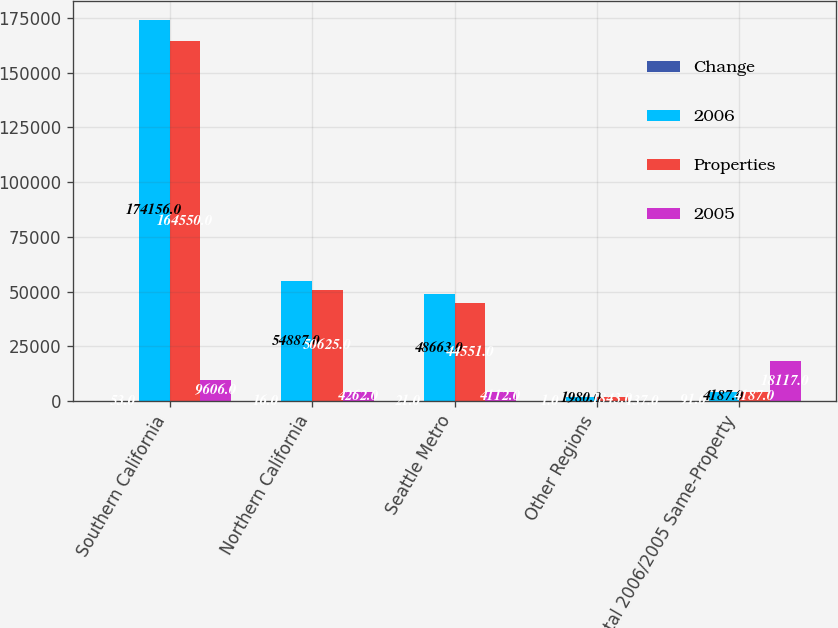Convert chart. <chart><loc_0><loc_0><loc_500><loc_500><stacked_bar_chart><ecel><fcel>Southern California<fcel>Northern California<fcel>Seattle Metro<fcel>Other Regions<fcel>Total 2006/2005 Same-Property<nl><fcel>Change<fcel>53<fcel>16<fcel>21<fcel>1<fcel>91<nl><fcel>2006<fcel>174156<fcel>54887<fcel>48663<fcel>1980<fcel>4187<nl><fcel>Properties<fcel>164550<fcel>50625<fcel>44551<fcel>1843<fcel>4187<nl><fcel>2005<fcel>9606<fcel>4262<fcel>4112<fcel>137<fcel>18117<nl></chart> 